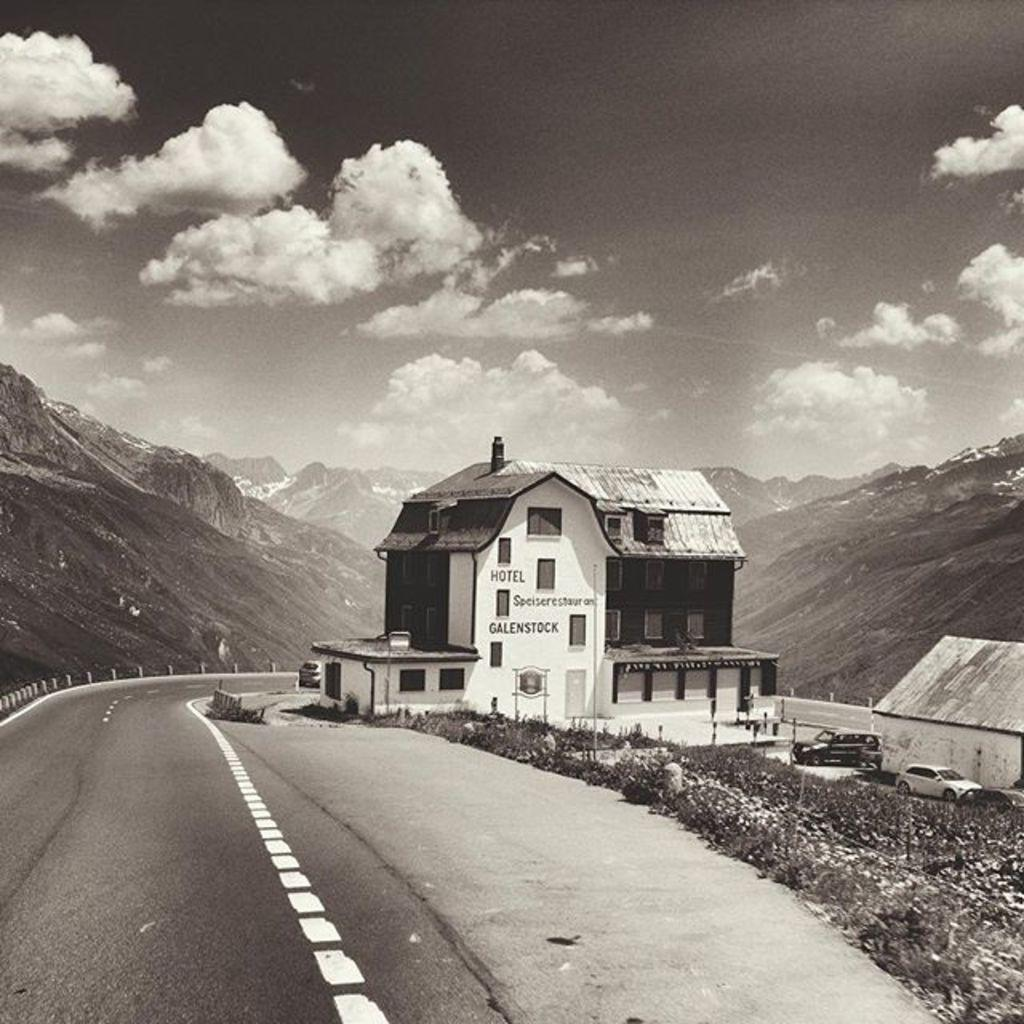What type of barrier can be seen in the image? There is a fence in the image. What type of vegetation is present in the image? There is grass in the image. What type of structures are visible in the image? There are houses in the image. What type of transportation can be seen in the image? There are vehicles in the image. What type of vertical structures are present in the image? There are poles in the image. What type of openings can be seen in the image? There are windows in the image. What type of natural formation can be seen in the image? There are mountains in the image. What part of the natural environment is visible in the image? The sky is visible in the image. What might be the location of the image? The image may have been taken on a road. How many knees are visible in the image? There are no knees visible in the image. What type of transportation can be seen flying in the image? There are no flying vehicles or transportation visible in the image. 